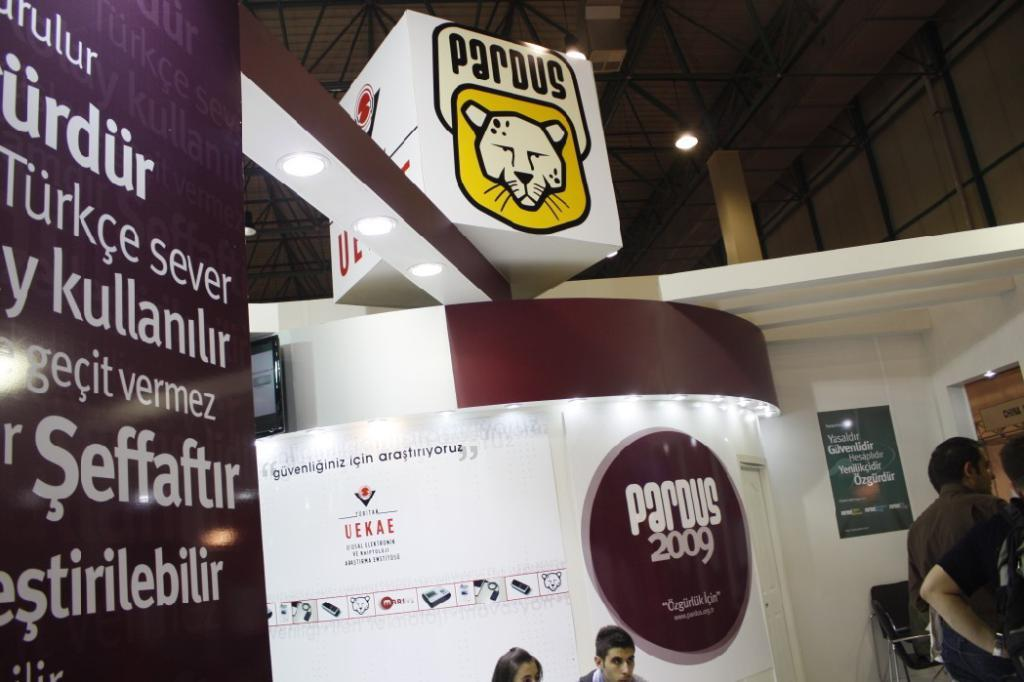<image>
Create a compact narrative representing the image presented. an information booth for Pardus 2009 uses white and burgundy colors 